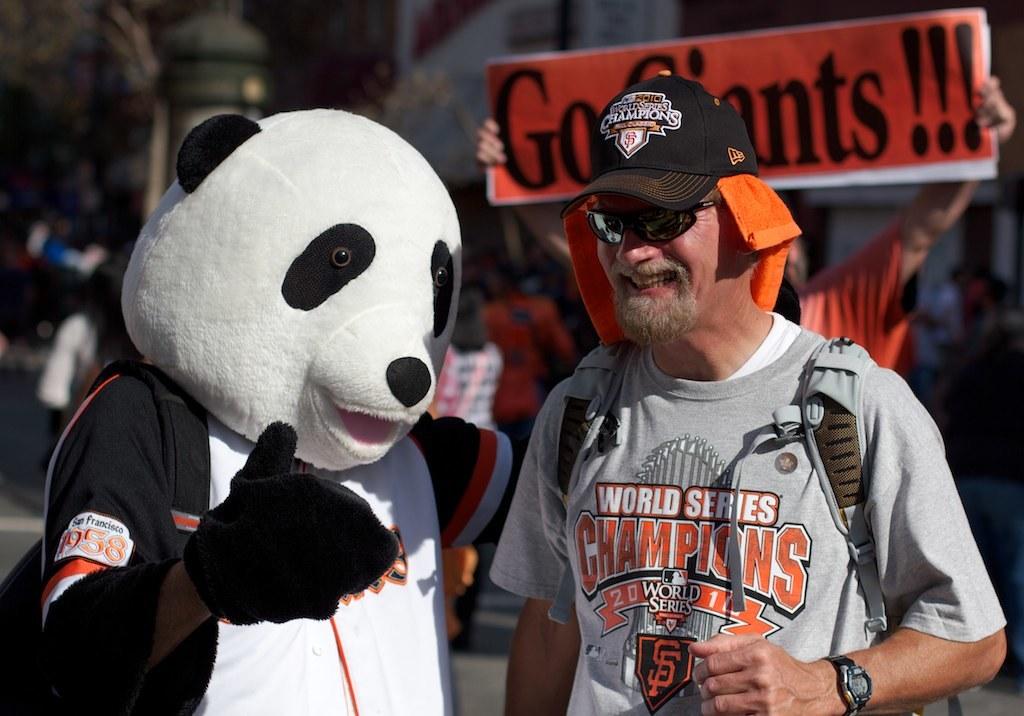What sport does the shirt represent?
Your answer should be very brief. Baseball. What title did the giants win, according to this man's shirt?
Offer a very short reply. World series. 